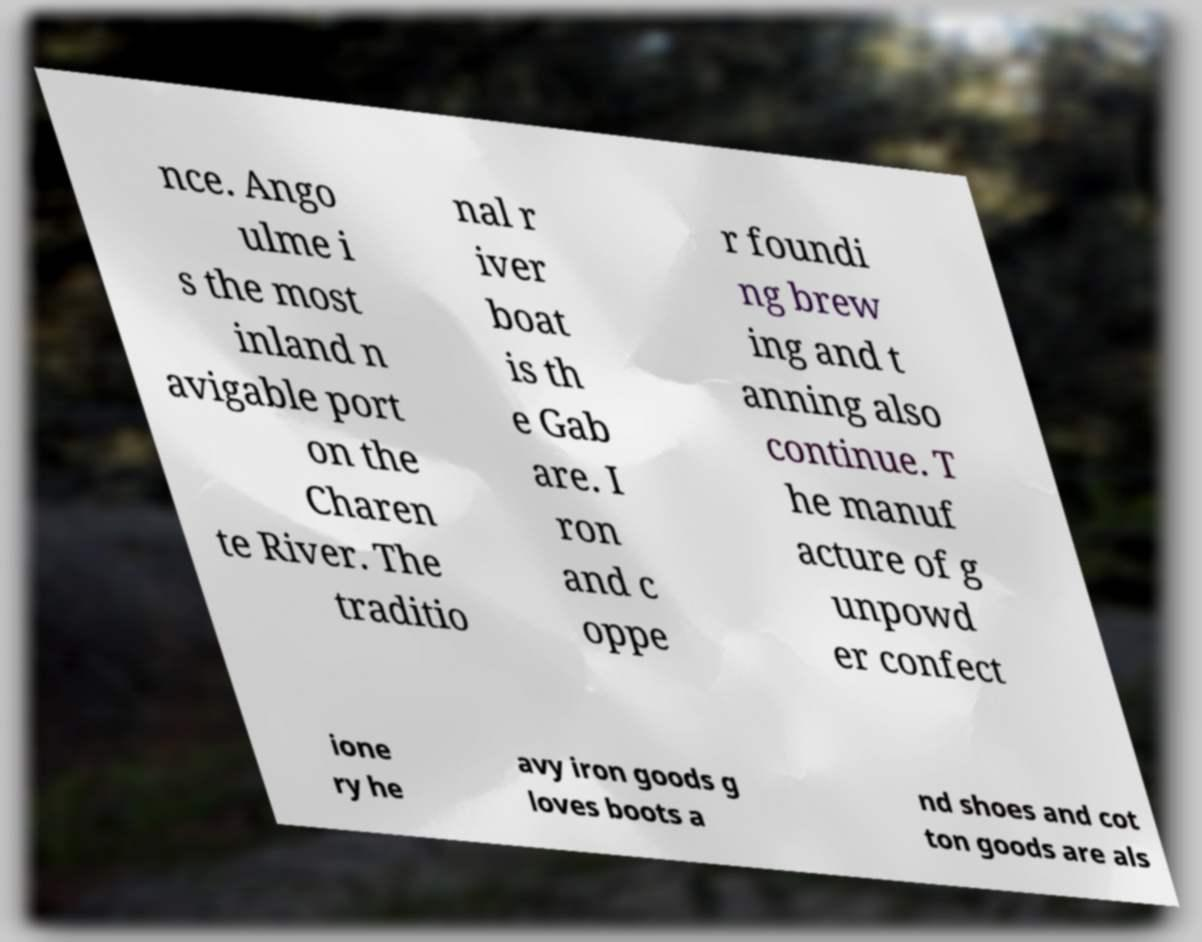Can you accurately transcribe the text from the provided image for me? nce. Ango ulme i s the most inland n avigable port on the Charen te River. The traditio nal r iver boat is th e Gab are. I ron and c oppe r foundi ng brew ing and t anning also continue. T he manuf acture of g unpowd er confect ione ry he avy iron goods g loves boots a nd shoes and cot ton goods are als 